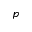<formula> <loc_0><loc_0><loc_500><loc_500>p</formula> 